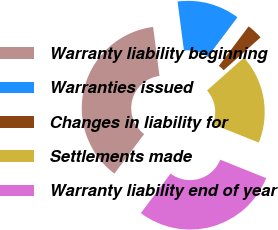Convert chart to OTSL. <chart><loc_0><loc_0><loc_500><loc_500><pie_chart><fcel>Warranty liability beginning<fcel>Warranties issued<fcel>Changes in liability for<fcel>Settlements made<fcel>Warranty liability end of year<nl><fcel>37.67%<fcel>12.33%<fcel>3.16%<fcel>17.64%<fcel>29.2%<nl></chart> 